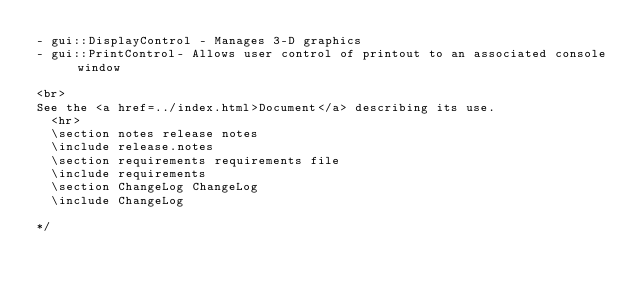Convert code to text. <code><loc_0><loc_0><loc_500><loc_500><_C_>- gui::DisplayControl - Manages 3-D graphics
- gui::PrintControl- Allows user control of printout to an associated console window

<br>
See the <a href=../index.html>Document</a> describing its use.
  <hr>
  \section notes release notes
  \include release.notes
  \section requirements requirements file
  \include requirements
  \section ChangeLog ChangeLog
  \include ChangeLog

*/

</code> 